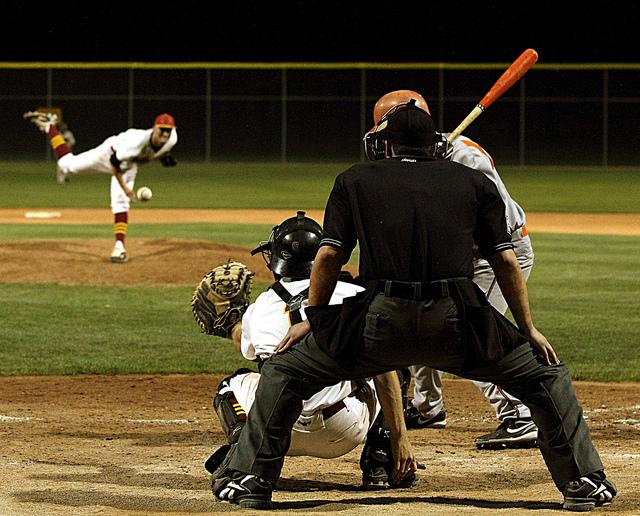What is the position of the person on the far left?
Write a very short answer. Pitcher. Which sport is this?
Be succinct. Baseball. What is the man in black's position?
Short answer required. Umpire. 